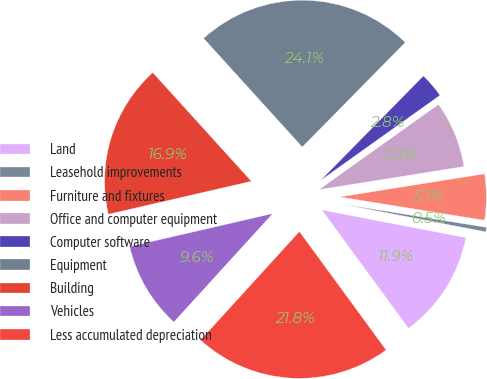Convert chart to OTSL. <chart><loc_0><loc_0><loc_500><loc_500><pie_chart><fcel>Land<fcel>Leasehold improvements<fcel>Furniture and fixtures<fcel>Office and computer equipment<fcel>Computer software<fcel>Equipment<fcel>Building<fcel>Vehicles<fcel>Less accumulated depreciation<nl><fcel>11.91%<fcel>0.49%<fcel>5.06%<fcel>7.34%<fcel>2.77%<fcel>24.1%<fcel>16.88%<fcel>9.63%<fcel>21.82%<nl></chart> 